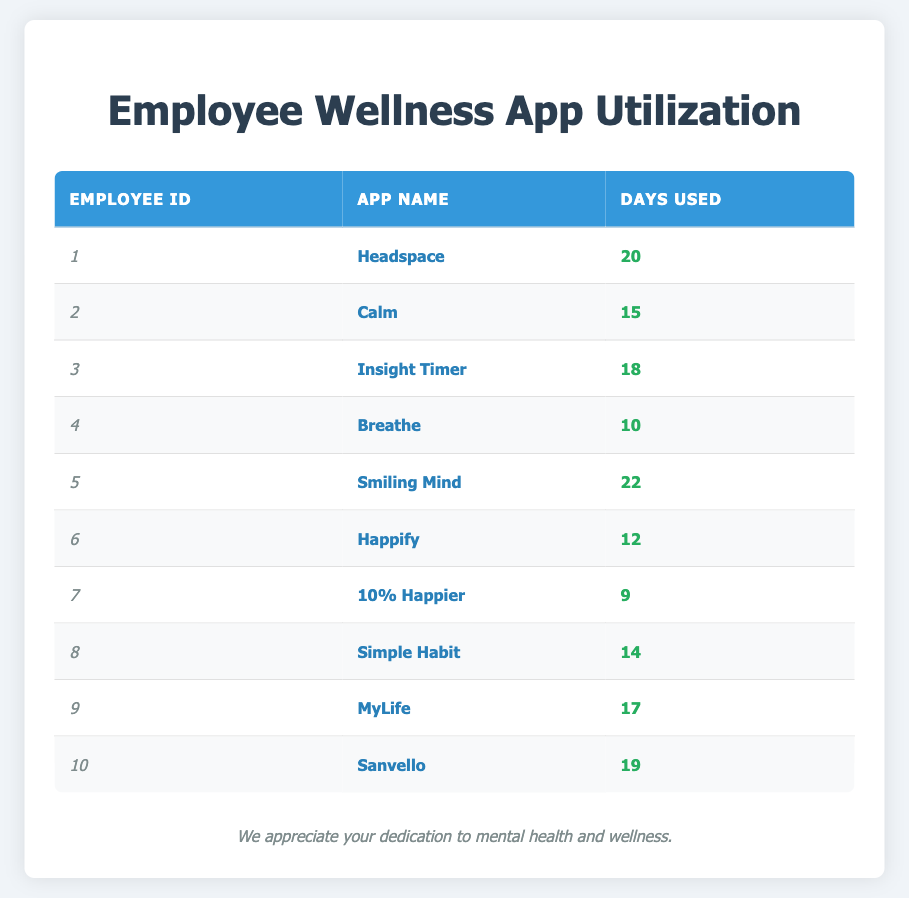What is the total number of days that employees used the apps? To find the total number of days, sum all the days used by each employee: 20 + 15 + 18 + 10 + 22 + 12 + 9 + 14 + 17 + 19 =  20 + 15 + 18 + 10 + 22 + 12 + 9 + 14 + 17 + 19 =  20 + 15 + 18 + 10 + 22 + 12 + 9 + 14 + 17 + 19 =  20 + 15 + 18 + 10 + 22 + 12 + 9 + 14 + 17 + 19 =  20 + 15 + 18 + 10 + 22 + 12 + 9 + 14 + 17 + 19 =  20 + 15 + 18 + 10 + 22 + 12 + 9 + 14 + 17 + 19 =  20 + 15 + 18 + 10 + 22 + 12 + 9 + 14 + 17 + 19 =  20 + 15 + 18 + 10 + 22 + 12 + 9 + 14 + 17 + 19 =  20 + 15 + 18 + 10 + 22 + 12 + 9 + 14 + 17 + 19 = 20 + 15 + 18 + 10 + 22 + 12 + 9 + 14 + 17 + 19 = 173
Answer: 173 Which employee used the most days on a mindfulness app? By looking at the "Days Used" column, Employee ID 5 with "Smiling Mind" used the most days at 22.
Answer: Employee ID 5 Is there an employee who used no apps at all? All employees listed in the table have used at least 9 days on an app, so there are no employees who used no apps.
Answer: No What is the average number of days each employee used an app? To calculate the average, we take the total number of days (173) and divide it by the number of employees (10): 173 / 10 = 17.3.
Answer: 17.3 Did more employees use the app "Calm" than "Happify"? Looking at the table, "Calm" (Employee ID 2) is used for 15 days and "Happify" (Employee ID 6) for 12 days, so yes, more employees used "Calm".
Answer: Yes What is the difference in days used between the employee who used the most days and the employee who used the least days? The maximum days used is by Employee ID 5 with 22 days, and the minimum is Employee ID 7 with 9 days. The difference is 22 - 9 = 13.
Answer: 13 Which app was used for the least number of days, and how many days was it used? From the table, "10% Happier" (Employee ID 7) was used for the least number of days, totaling 9 days.
Answer: 10% Happier, 9 days How many employees used their chosen app for more than 15 days? By analyzing the days used, we count employees 1 (20 days), 3 (18 days), 5 (22 days), 9 (17 days), and 10 (19 days), which totals 5 employees who used their app for more than 15 days.
Answer: 5 